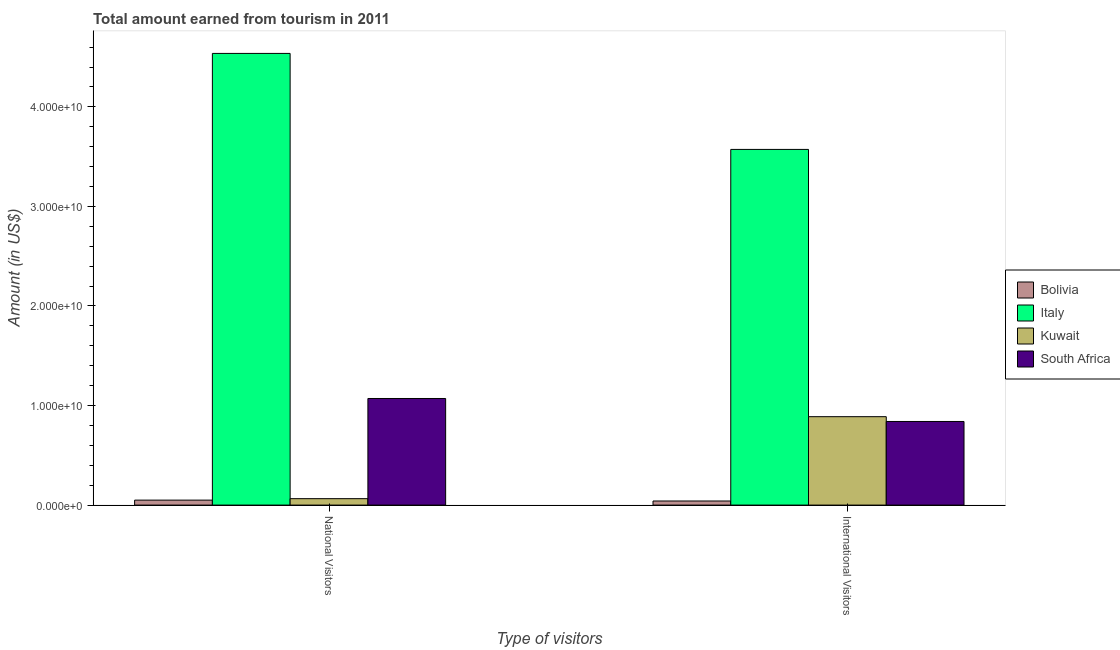How many groups of bars are there?
Your response must be concise. 2. Are the number of bars per tick equal to the number of legend labels?
Make the answer very short. Yes. Are the number of bars on each tick of the X-axis equal?
Offer a terse response. Yes. How many bars are there on the 2nd tick from the left?
Make the answer very short. 4. How many bars are there on the 1st tick from the right?
Provide a succinct answer. 4. What is the label of the 1st group of bars from the left?
Your answer should be compact. National Visitors. What is the amount earned from international visitors in Italy?
Provide a succinct answer. 3.57e+1. Across all countries, what is the maximum amount earned from national visitors?
Provide a succinct answer. 4.54e+1. Across all countries, what is the minimum amount earned from international visitors?
Ensure brevity in your answer.  4.10e+08. What is the total amount earned from international visitors in the graph?
Ensure brevity in your answer.  5.34e+1. What is the difference between the amount earned from international visitors in Bolivia and that in Italy?
Ensure brevity in your answer.  -3.53e+1. What is the difference between the amount earned from international visitors in Bolivia and the amount earned from national visitors in Kuwait?
Ensure brevity in your answer.  -2.34e+08. What is the average amount earned from international visitors per country?
Your response must be concise. 1.34e+1. What is the difference between the amount earned from national visitors and amount earned from international visitors in South Africa?
Make the answer very short. 2.31e+09. In how many countries, is the amount earned from national visitors greater than 44000000000 US$?
Keep it short and to the point. 1. What is the ratio of the amount earned from international visitors in Bolivia to that in Italy?
Offer a terse response. 0.01. In how many countries, is the amount earned from national visitors greater than the average amount earned from national visitors taken over all countries?
Offer a very short reply. 1. What does the 2nd bar from the right in National Visitors represents?
Provide a short and direct response. Kuwait. How many bars are there?
Your response must be concise. 8. Are all the bars in the graph horizontal?
Your answer should be very brief. No. How many countries are there in the graph?
Offer a very short reply. 4. What is the difference between two consecutive major ticks on the Y-axis?
Provide a short and direct response. 1.00e+1. Are the values on the major ticks of Y-axis written in scientific E-notation?
Provide a succinct answer. Yes. Does the graph contain any zero values?
Give a very brief answer. No. Does the graph contain grids?
Ensure brevity in your answer.  No. Where does the legend appear in the graph?
Your answer should be compact. Center right. How are the legend labels stacked?
Offer a terse response. Vertical. What is the title of the graph?
Ensure brevity in your answer.  Total amount earned from tourism in 2011. What is the label or title of the X-axis?
Keep it short and to the point. Type of visitors. What is the Amount (in US$) in Bolivia in National Visitors?
Provide a succinct answer. 4.99e+08. What is the Amount (in US$) in Italy in National Visitors?
Your answer should be compact. 4.54e+1. What is the Amount (in US$) in Kuwait in National Visitors?
Make the answer very short. 6.44e+08. What is the Amount (in US$) of South Africa in National Visitors?
Keep it short and to the point. 1.07e+1. What is the Amount (in US$) in Bolivia in International Visitors?
Offer a very short reply. 4.10e+08. What is the Amount (in US$) in Italy in International Visitors?
Provide a succinct answer. 3.57e+1. What is the Amount (in US$) of Kuwait in International Visitors?
Provide a short and direct response. 8.88e+09. What is the Amount (in US$) of South Africa in International Visitors?
Your answer should be very brief. 8.40e+09. Across all Type of visitors, what is the maximum Amount (in US$) in Bolivia?
Your answer should be compact. 4.99e+08. Across all Type of visitors, what is the maximum Amount (in US$) in Italy?
Offer a very short reply. 4.54e+1. Across all Type of visitors, what is the maximum Amount (in US$) of Kuwait?
Provide a short and direct response. 8.88e+09. Across all Type of visitors, what is the maximum Amount (in US$) in South Africa?
Offer a terse response. 1.07e+1. Across all Type of visitors, what is the minimum Amount (in US$) of Bolivia?
Your answer should be compact. 4.10e+08. Across all Type of visitors, what is the minimum Amount (in US$) in Italy?
Your answer should be very brief. 3.57e+1. Across all Type of visitors, what is the minimum Amount (in US$) in Kuwait?
Provide a succinct answer. 6.44e+08. Across all Type of visitors, what is the minimum Amount (in US$) of South Africa?
Provide a succinct answer. 8.40e+09. What is the total Amount (in US$) of Bolivia in the graph?
Provide a short and direct response. 9.09e+08. What is the total Amount (in US$) in Italy in the graph?
Your response must be concise. 8.11e+1. What is the total Amount (in US$) of Kuwait in the graph?
Keep it short and to the point. 9.52e+09. What is the total Amount (in US$) of South Africa in the graph?
Provide a short and direct response. 1.91e+1. What is the difference between the Amount (in US$) in Bolivia in National Visitors and that in International Visitors?
Make the answer very short. 8.90e+07. What is the difference between the Amount (in US$) of Italy in National Visitors and that in International Visitors?
Ensure brevity in your answer.  9.64e+09. What is the difference between the Amount (in US$) of Kuwait in National Visitors and that in International Visitors?
Make the answer very short. -8.24e+09. What is the difference between the Amount (in US$) of South Africa in National Visitors and that in International Visitors?
Your answer should be compact. 2.31e+09. What is the difference between the Amount (in US$) in Bolivia in National Visitors and the Amount (in US$) in Italy in International Visitors?
Provide a short and direct response. -3.52e+1. What is the difference between the Amount (in US$) of Bolivia in National Visitors and the Amount (in US$) of Kuwait in International Visitors?
Ensure brevity in your answer.  -8.38e+09. What is the difference between the Amount (in US$) in Bolivia in National Visitors and the Amount (in US$) in South Africa in International Visitors?
Offer a very short reply. -7.90e+09. What is the difference between the Amount (in US$) in Italy in National Visitors and the Amount (in US$) in Kuwait in International Visitors?
Make the answer very short. 3.65e+1. What is the difference between the Amount (in US$) in Italy in National Visitors and the Amount (in US$) in South Africa in International Visitors?
Provide a succinct answer. 3.70e+1. What is the difference between the Amount (in US$) of Kuwait in National Visitors and the Amount (in US$) of South Africa in International Visitors?
Provide a succinct answer. -7.75e+09. What is the average Amount (in US$) of Bolivia per Type of visitors?
Provide a short and direct response. 4.54e+08. What is the average Amount (in US$) in Italy per Type of visitors?
Your answer should be very brief. 4.05e+1. What is the average Amount (in US$) of Kuwait per Type of visitors?
Your response must be concise. 4.76e+09. What is the average Amount (in US$) in South Africa per Type of visitors?
Offer a terse response. 9.55e+09. What is the difference between the Amount (in US$) of Bolivia and Amount (in US$) of Italy in National Visitors?
Offer a terse response. -4.49e+1. What is the difference between the Amount (in US$) of Bolivia and Amount (in US$) of Kuwait in National Visitors?
Ensure brevity in your answer.  -1.45e+08. What is the difference between the Amount (in US$) of Bolivia and Amount (in US$) of South Africa in National Visitors?
Your answer should be very brief. -1.02e+1. What is the difference between the Amount (in US$) of Italy and Amount (in US$) of Kuwait in National Visitors?
Make the answer very short. 4.47e+1. What is the difference between the Amount (in US$) of Italy and Amount (in US$) of South Africa in National Visitors?
Provide a succinct answer. 3.47e+1. What is the difference between the Amount (in US$) of Kuwait and Amount (in US$) of South Africa in National Visitors?
Provide a short and direct response. -1.01e+1. What is the difference between the Amount (in US$) of Bolivia and Amount (in US$) of Italy in International Visitors?
Your answer should be compact. -3.53e+1. What is the difference between the Amount (in US$) in Bolivia and Amount (in US$) in Kuwait in International Visitors?
Provide a short and direct response. -8.47e+09. What is the difference between the Amount (in US$) of Bolivia and Amount (in US$) of South Africa in International Visitors?
Keep it short and to the point. -7.99e+09. What is the difference between the Amount (in US$) of Italy and Amount (in US$) of Kuwait in International Visitors?
Provide a short and direct response. 2.68e+1. What is the difference between the Amount (in US$) in Italy and Amount (in US$) in South Africa in International Visitors?
Provide a succinct answer. 2.73e+1. What is the difference between the Amount (in US$) in Kuwait and Amount (in US$) in South Africa in International Visitors?
Ensure brevity in your answer.  4.82e+08. What is the ratio of the Amount (in US$) of Bolivia in National Visitors to that in International Visitors?
Your response must be concise. 1.22. What is the ratio of the Amount (in US$) of Italy in National Visitors to that in International Visitors?
Offer a terse response. 1.27. What is the ratio of the Amount (in US$) of Kuwait in National Visitors to that in International Visitors?
Your answer should be compact. 0.07. What is the ratio of the Amount (in US$) of South Africa in National Visitors to that in International Visitors?
Your response must be concise. 1.28. What is the difference between the highest and the second highest Amount (in US$) of Bolivia?
Your answer should be compact. 8.90e+07. What is the difference between the highest and the second highest Amount (in US$) of Italy?
Make the answer very short. 9.64e+09. What is the difference between the highest and the second highest Amount (in US$) of Kuwait?
Your answer should be compact. 8.24e+09. What is the difference between the highest and the second highest Amount (in US$) in South Africa?
Your response must be concise. 2.31e+09. What is the difference between the highest and the lowest Amount (in US$) in Bolivia?
Make the answer very short. 8.90e+07. What is the difference between the highest and the lowest Amount (in US$) in Italy?
Give a very brief answer. 9.64e+09. What is the difference between the highest and the lowest Amount (in US$) in Kuwait?
Offer a very short reply. 8.24e+09. What is the difference between the highest and the lowest Amount (in US$) of South Africa?
Provide a short and direct response. 2.31e+09. 